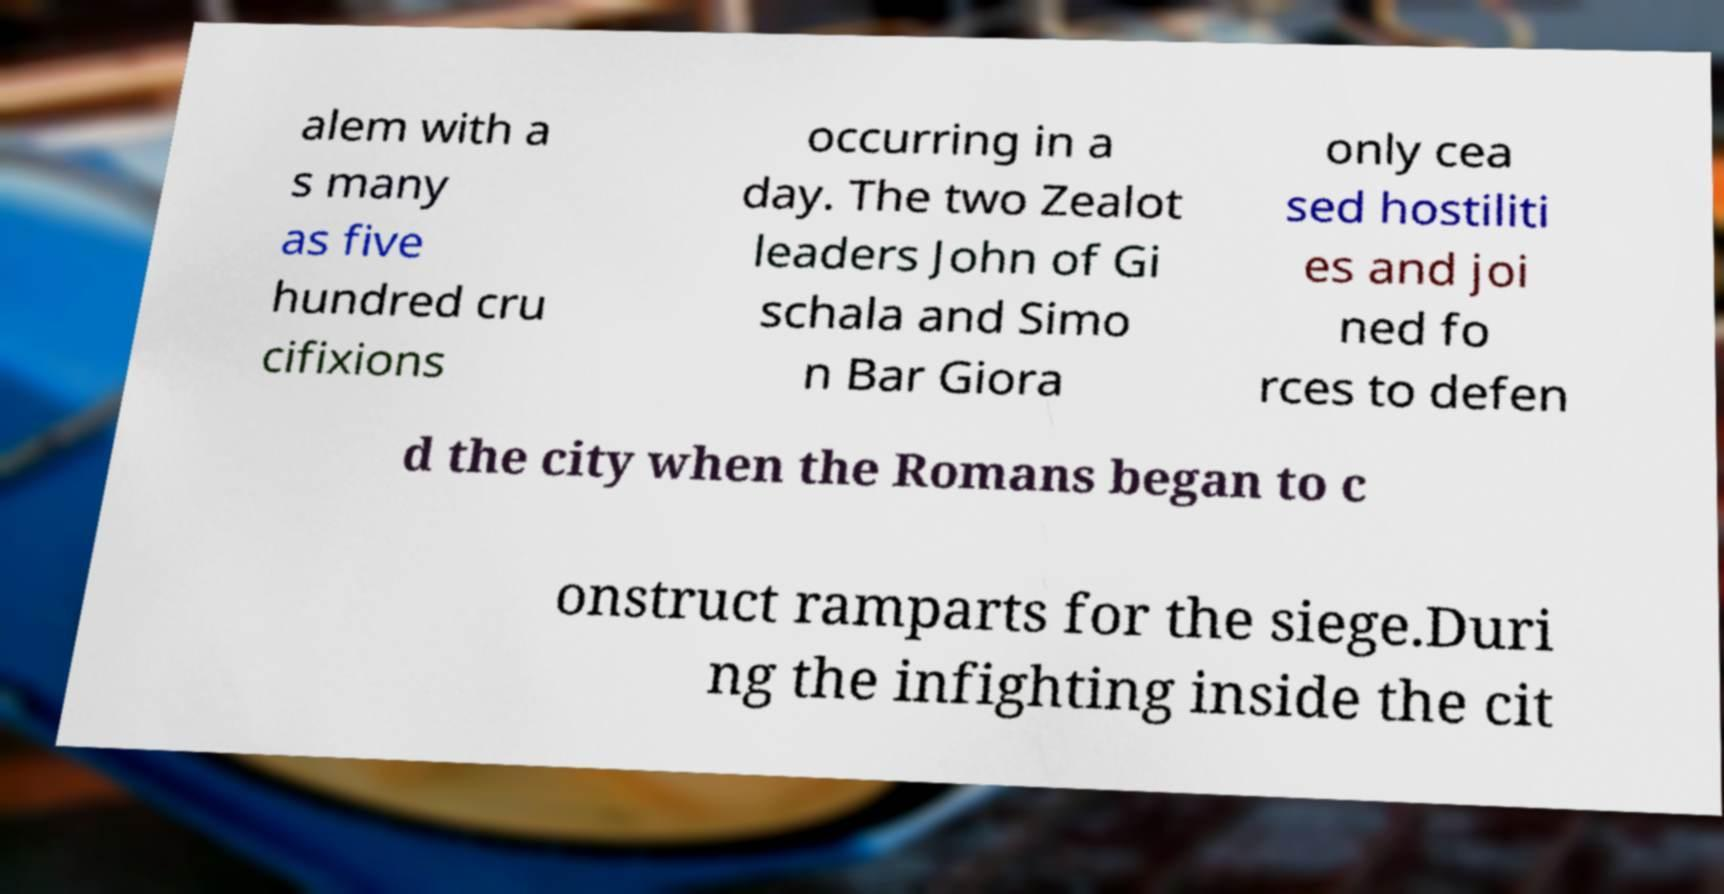Can you accurately transcribe the text from the provided image for me? alem with a s many as five hundred cru cifixions occurring in a day. The two Zealot leaders John of Gi schala and Simo n Bar Giora only cea sed hostiliti es and joi ned fo rces to defen d the city when the Romans began to c onstruct ramparts for the siege.Duri ng the infighting inside the cit 